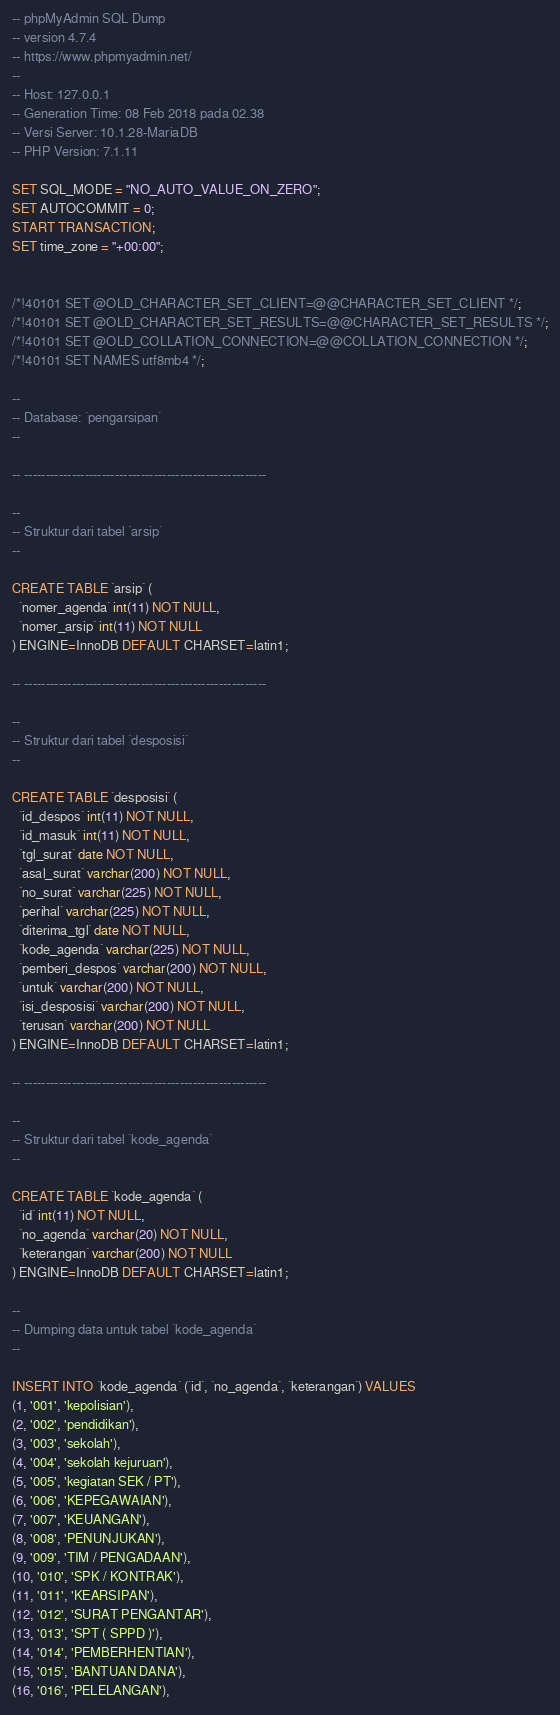Convert code to text. <code><loc_0><loc_0><loc_500><loc_500><_SQL_>-- phpMyAdmin SQL Dump
-- version 4.7.4
-- https://www.phpmyadmin.net/
--
-- Host: 127.0.0.1
-- Generation Time: 08 Feb 2018 pada 02.38
-- Versi Server: 10.1.28-MariaDB
-- PHP Version: 7.1.11

SET SQL_MODE = "NO_AUTO_VALUE_ON_ZERO";
SET AUTOCOMMIT = 0;
START TRANSACTION;
SET time_zone = "+00:00";


/*!40101 SET @OLD_CHARACTER_SET_CLIENT=@@CHARACTER_SET_CLIENT */;
/*!40101 SET @OLD_CHARACTER_SET_RESULTS=@@CHARACTER_SET_RESULTS */;
/*!40101 SET @OLD_COLLATION_CONNECTION=@@COLLATION_CONNECTION */;
/*!40101 SET NAMES utf8mb4 */;

--
-- Database: `pengarsipan`
--

-- --------------------------------------------------------

--
-- Struktur dari tabel `arsip`
--

CREATE TABLE `arsip` (
  `nomer_agenda` int(11) NOT NULL,
  `nomer_arsip` int(11) NOT NULL
) ENGINE=InnoDB DEFAULT CHARSET=latin1;

-- --------------------------------------------------------

--
-- Struktur dari tabel `desposisi`
--

CREATE TABLE `desposisi` (
  `id_despos` int(11) NOT NULL,
  `id_masuk` int(11) NOT NULL,
  `tgl_surat` date NOT NULL,
  `asal_surat` varchar(200) NOT NULL,
  `no_surat` varchar(225) NOT NULL,
  `perihal` varchar(225) NOT NULL,
  `diterima_tgl` date NOT NULL,
  `kode_agenda` varchar(225) NOT NULL,
  `pemberi_despos` varchar(200) NOT NULL,
  `untuk` varchar(200) NOT NULL,
  `isi_desposisi` varchar(200) NOT NULL,
  `terusan` varchar(200) NOT NULL
) ENGINE=InnoDB DEFAULT CHARSET=latin1;

-- --------------------------------------------------------

--
-- Struktur dari tabel `kode_agenda`
--

CREATE TABLE `kode_agenda` (
  `id` int(11) NOT NULL,
  `no_agenda` varchar(20) NOT NULL,
  `keterangan` varchar(200) NOT NULL
) ENGINE=InnoDB DEFAULT CHARSET=latin1;

--
-- Dumping data untuk tabel `kode_agenda`
--

INSERT INTO `kode_agenda` (`id`, `no_agenda`, `keterangan`) VALUES
(1, '001', 'kepolisian'),
(2, '002', 'pendidikan'),
(3, '003', 'sekolah'),
(4, '004', 'sekolah kejuruan'),
(5, '005', 'kegiatan SEK / PT'),
(6, '006', 'KEPEGAWAIAN'),
(7, '007', 'KEUANGAN'),
(8, '008', 'PENUNJUKAN'),
(9, '009', 'TIM / PENGADAAN'),
(10, '010', 'SPK / KONTRAK'),
(11, '011', 'KEARSIPAN'),
(12, '012', 'SURAT PENGANTAR'),
(13, '013', 'SPT ( SPPD )'),
(14, '014', 'PEMBERHENTIAN'),
(15, '015', 'BANTUAN DANA'),
(16, '016', 'PELELANGAN'),</code> 